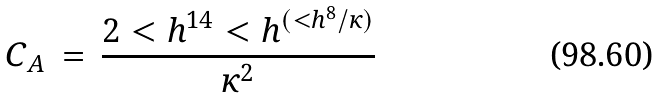<formula> <loc_0><loc_0><loc_500><loc_500>C _ { A } \, = \, \frac { 2 < h ^ { 1 4 } < h ^ { ( < h ^ { 8 } / \kappa ) } } { \kappa ^ { 2 } }</formula> 